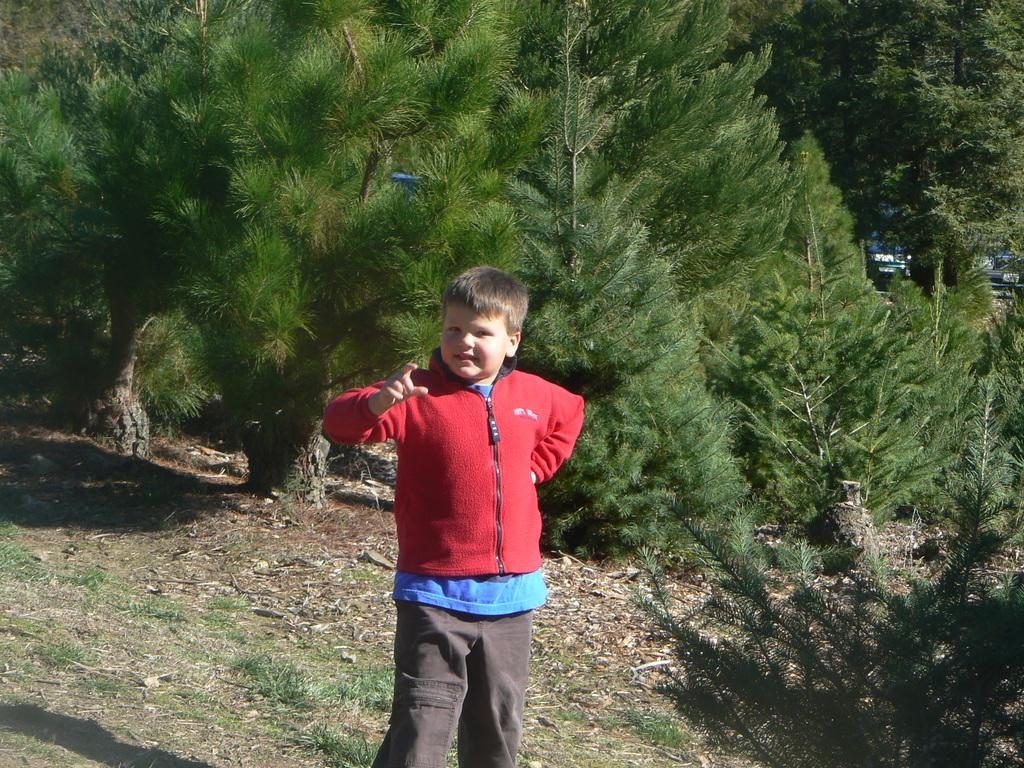What is located in the foreground of the picture? There is a plant, grass, dry leaves, and a kid in the foreground of the picture. What type of vegetation can be seen in the foreground? There is grass and a plant in the foreground of the picture. What is the condition of the leaves in the foreground? The leaves in the foreground are dry. What can be seen in the background of the picture? There are trees in the background of the picture. What is the weight of the baby in the picture? There is no baby present in the picture; it features a kid instead. Is there a hole in the ground visible in the picture? There is no hole in the ground visible in the picture. 